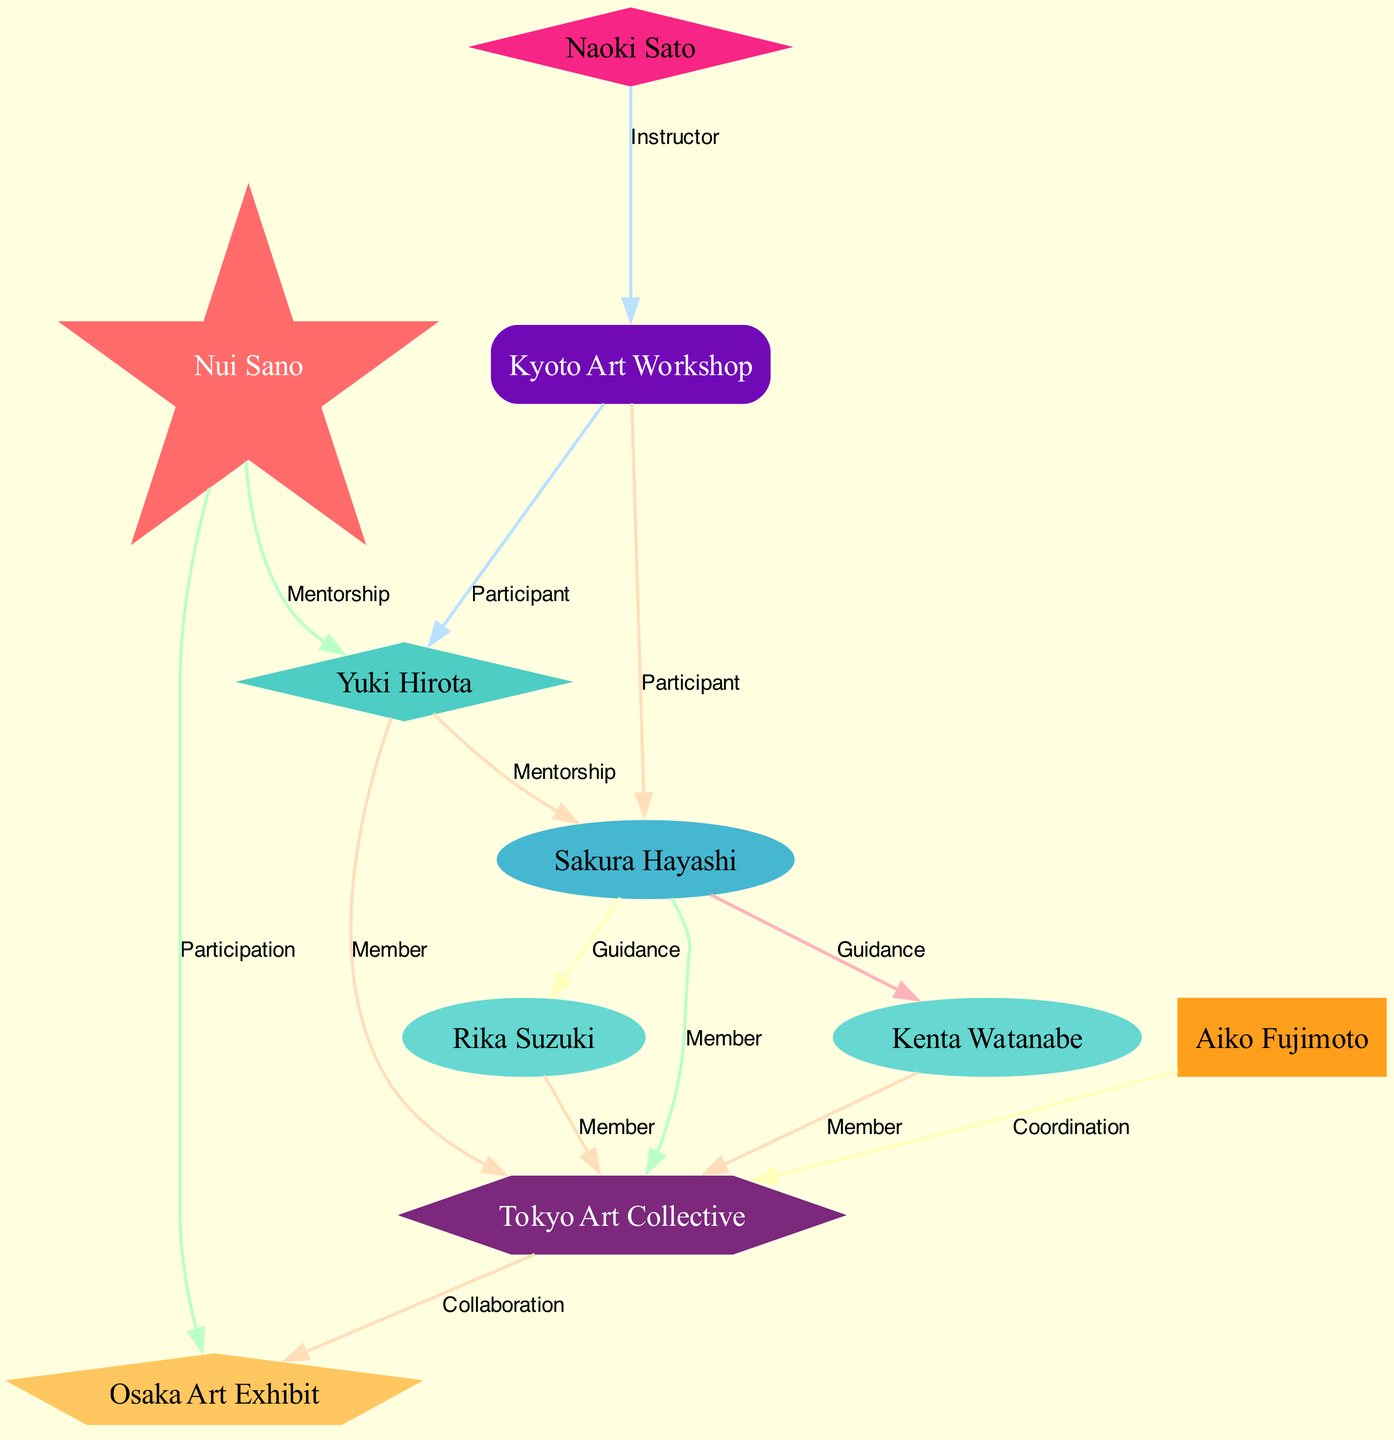What role does Nui Sano play in the community? Referring to the diagram, Nui Sano is identified with the label "Master Artist," which designates his prominent position within the artist community.
Answer: Master Artist How many edges are there in total? By counting the connections depicted in the diagram, there are a total of 14 edges. Each edge represents a relationship between two nodes.
Answer: 14 Who is the mentor of Yuki Hirota? The diagram connects Yuki Hirota to Nui Sano through an edge labeled "Mentorship," indicating that Nui Sano is his mentor.
Answer: Nui Sano Which artist is involved in the Tokyo Art Collective? The diagram shows multiple connections from artists to the Tokyo Art Collective: Yuki Hirota, Sakura Hayashi, Kenta Watanabe, and Rika Suzuki are all labeled as members.
Answer: Yuki Hirota, Sakura Hayashi, Kenta Watanabe, Rika Suzuki What type of connection exists between Sakura Hayashi and Kenta Watanabe? The edge between Sakura Hayashi and Kenta Watanabe is labeled "Guidance," indicating a supportive relationship where Sakura provides guidance to Kenta.
Answer: Guidance How does Aiko Fujimoto contribute to the Tokyo Art Collective? Aiko Fujimoto is connected to the Tokyo Art Collective with an edge labeled "Coordination," showing that she plays a role in organizing or coordinating activities within this group.
Answer: Coordination Which two nodes show a direct relationship involving workshops? The diagram includes a relationship where Naoki Sato is identified as an instructor at the Kyoto Art Workshop, which then connects to Yuki Hirota and Sakura Hayashi. This shows a direct relationship involving workshops.
Answer: Kyoto Art Workshop Which exhibition is associated with Nui Sano? The edge between Nui Sano and the Osaka Art Exhibit is labeled "Participation," indicating that Nui Sano has a role in this exhibition.
Answer: Osaka Art Exhibit How many young artists are members of the Tokyo Art Collective? Both Kenta Watanabe and Rika Suzuki are labeled as "Young Artist" and are shown as members of the Tokyo Art Collective, giving a total of 2 young artists in this group.
Answer: 2 